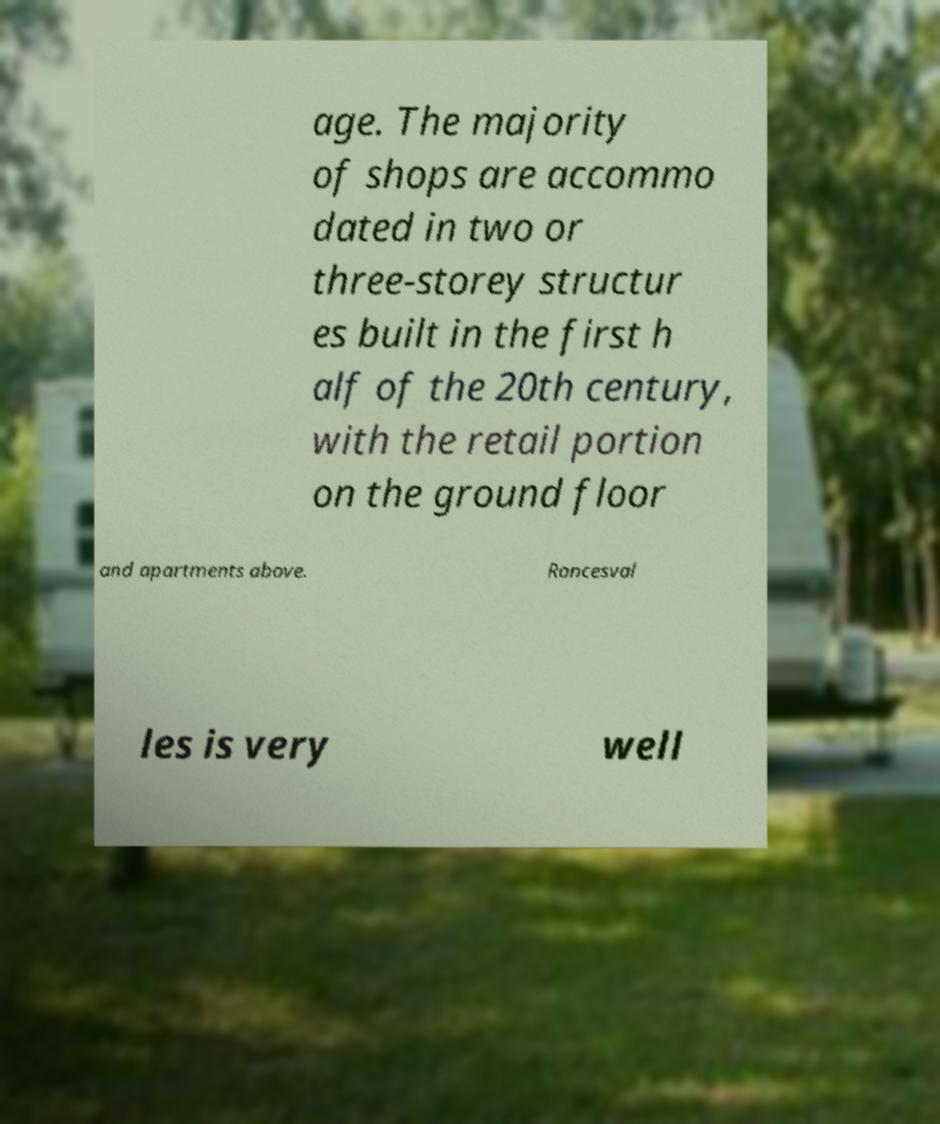Can you accurately transcribe the text from the provided image for me? age. The majority of shops are accommo dated in two or three-storey structur es built in the first h alf of the 20th century, with the retail portion on the ground floor and apartments above. Roncesval les is very well 